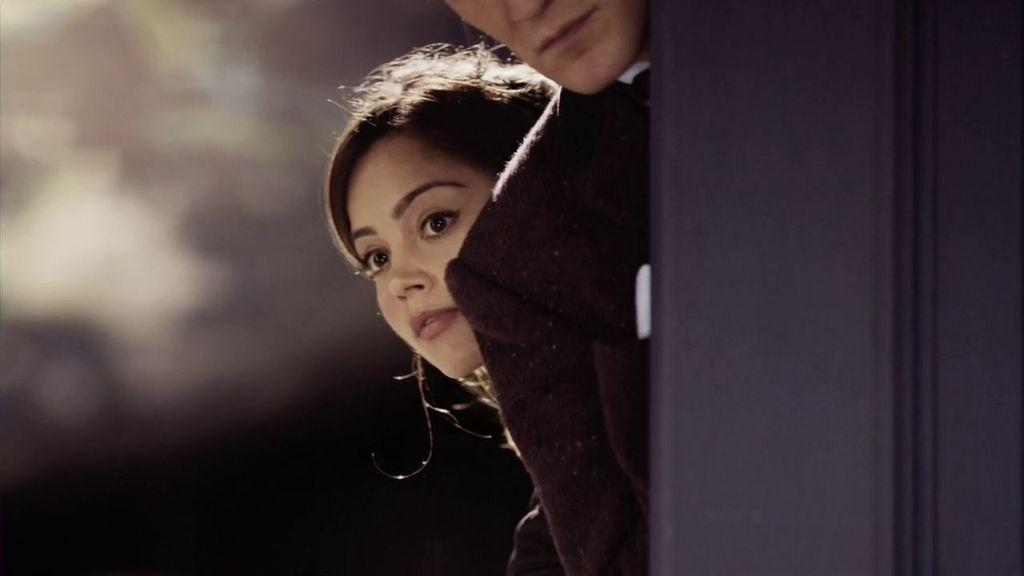What is located on the right side of the image? There is a door on the right side of the image. How many people are present in the image? There are two people in the image. Can you describe the background of the image? The background of the image is blurred. What type of alarm can be heard in the image? There is no alarm present in the image, and therefore no sound can be heard. What territory is being claimed by the two people in the image? There is no indication of territory being claimed in the image; it only shows two people and a door. 